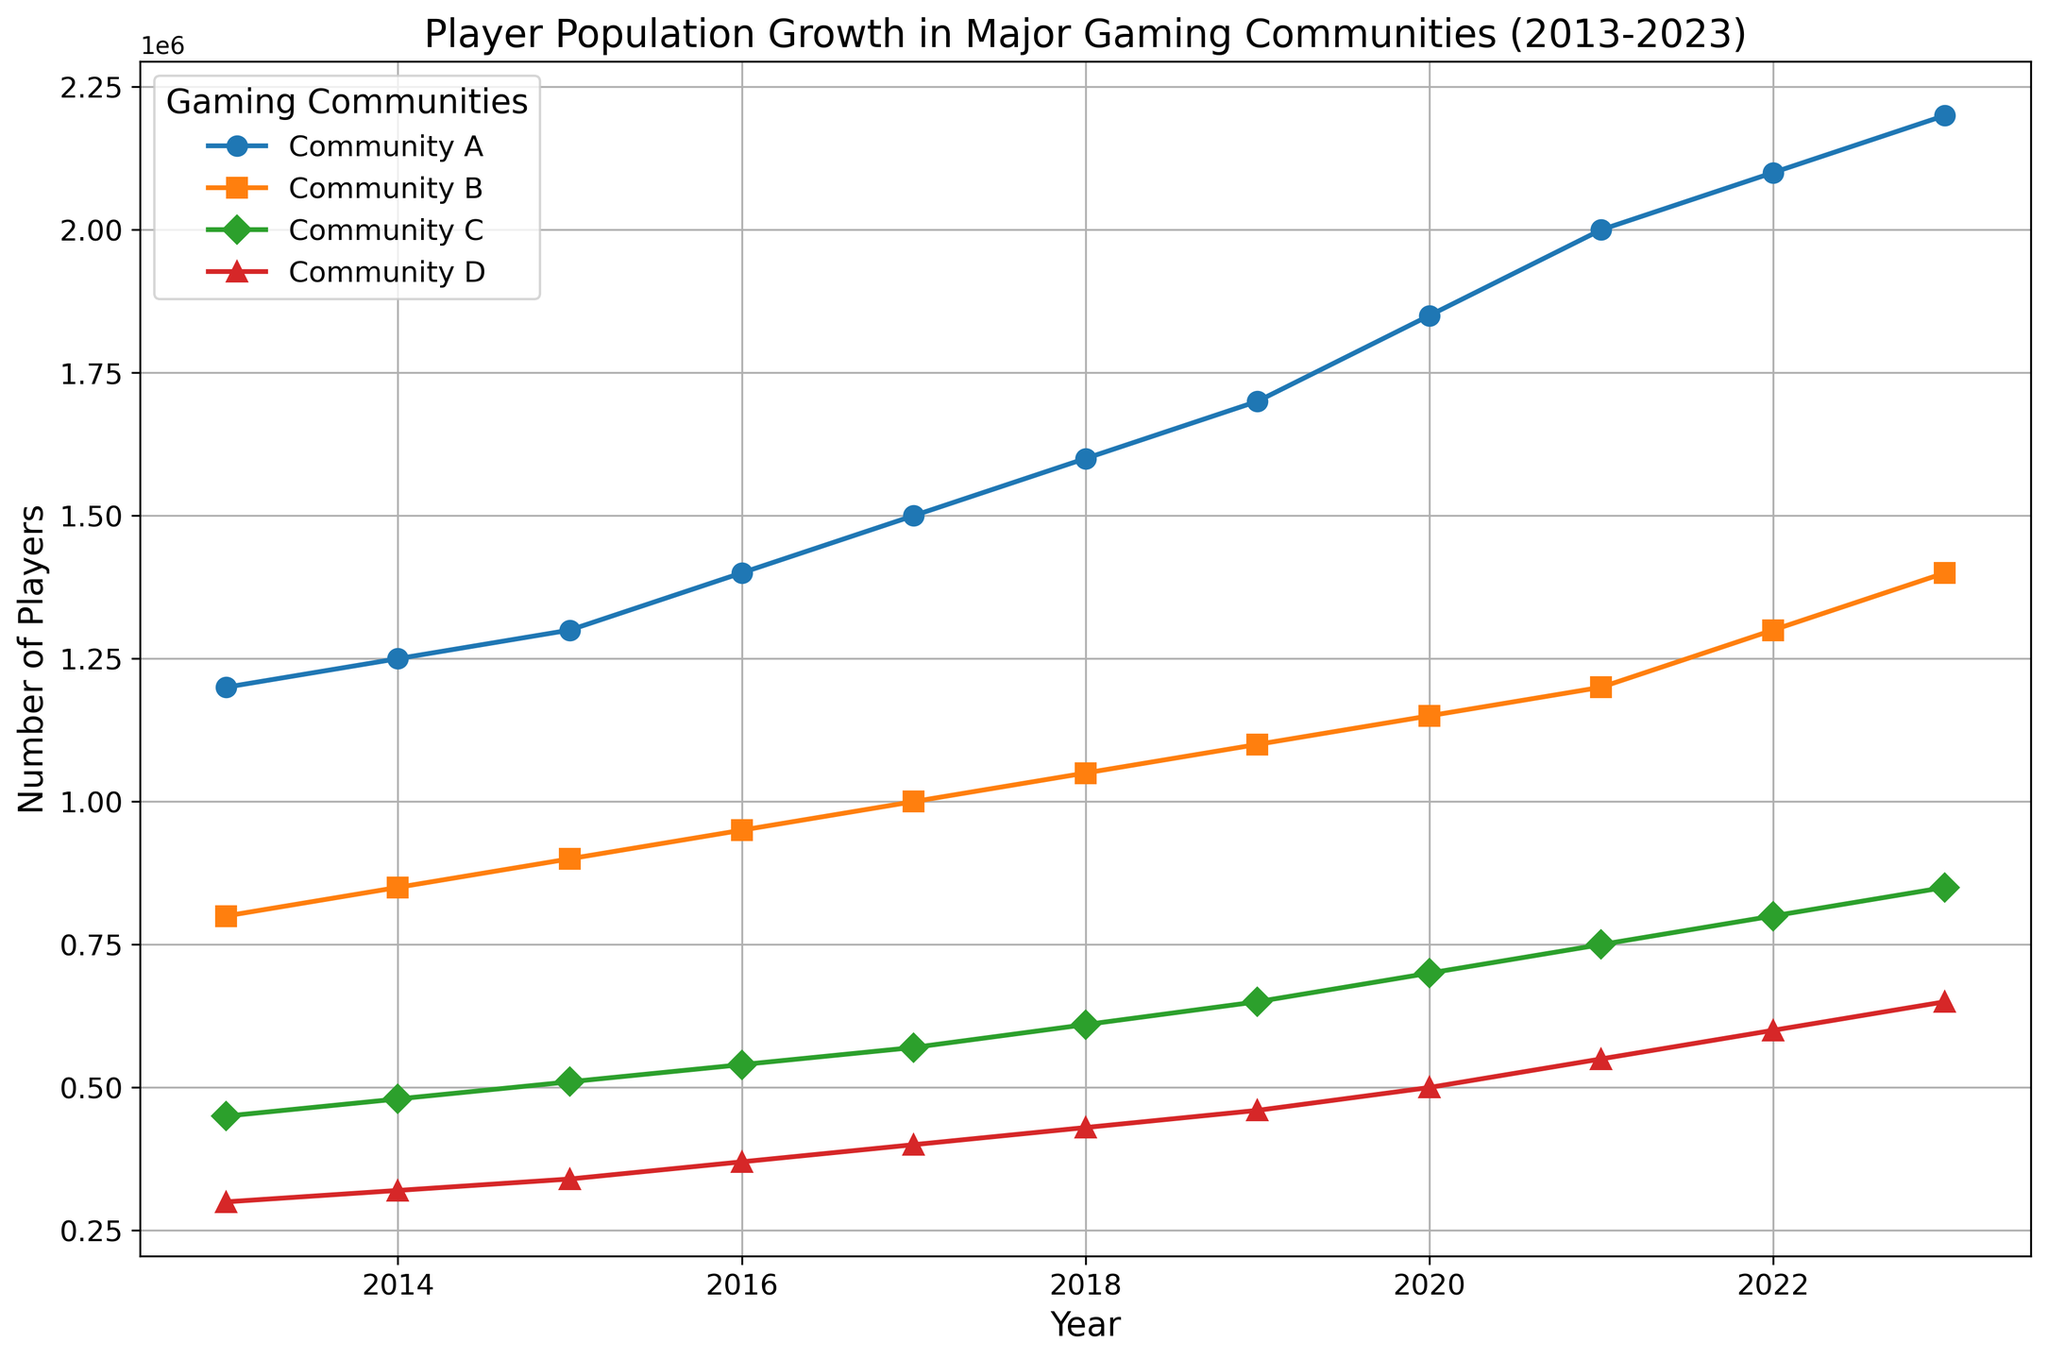What was the player population of Community B in 2020? Look at the data point for Community B in the year 2020 and read the value directly from the chart.
Answer: 1,150,000 Which community had the highest player population in 2023? Compare the end points of all lines in the year 2023 and identify the one that reaches the highest value on the y-axis.
Answer: Community A How did the population growth trend of Community C compare to Community D from 2019 to 2023? Analyze the slope of the lines representing Community C and Community D between 2019 and 2023. Community C shows a steady and greater upward trend compared to Community D.
Answer: Community C grew faster What is the difference in player population between Community A and Community D in 2021? Find the player populations of both Community A and Community D in 2021 from the chart and subtract the population of Community D from that of Community A.
Answer: 1,450,000 Over the entire decade, which community showed the most consistent growth pattern? Examine the slopes of the lines representing each community over the years; the line with a uniform slope indicates consistent growth.
Answer: Community A What is the average player population for Community B over the 10-year period? Sum the player populations of Community B for each year from 2013 to 2023, then divide by the number of years (11). The sum is: 800,000 + 850,000 + 900,000 + 950,000 + 1,000,000 + 1,050,000 + 1,100,000 + 1,150,000 + 1,200,000 + 1,300,000 + 1,400,000 = 11,700,000. Dividing by 11 gives approximately 1,063,636.
Answer: 1,063,636 Which year did Community D see the highest yearly increase in player population? Calculate the difference in player population for Community D year-on-year and identify the year with the largest increase. The highest increase is from 2021 to 2022, with a difference of 50,000 players (600,000 - 550,000).
Answer: 2022 What is the total player population for all communities combined in 2017? Sum the player populations of Communities A, B, C, and D for the year 2017. The values are 1,500,000 + 1,000,000 + 570,000 + 400,000 = 3,470,000.
Answer: 3,470,000 Between 2015 and 2018, which community had the greatest overall increase in player population? Calculate the increase for each community by subtracting the 2015 values from the 2018 values: Community A (1,600,000 - 1,300,000 = 300,000), Community B (1,050,000 - 900,000 = 150,000), Community C (610,000 - 510,000 = 100,000), Community D (430,000 - 340,000 = 90,000). Community A shows the greatest increase.
Answer: Community A 